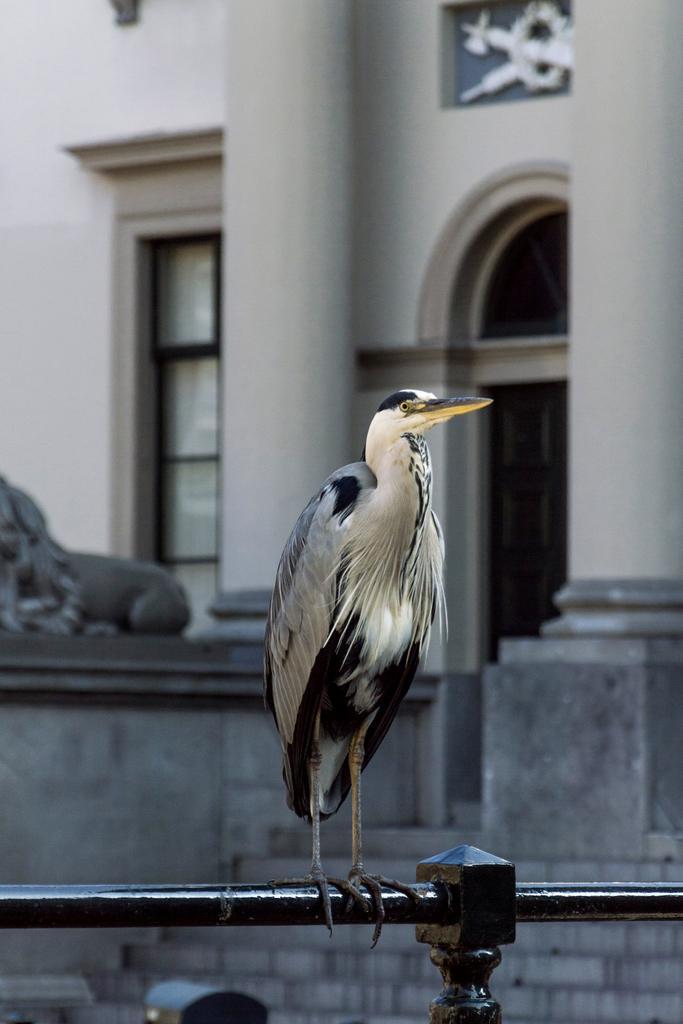Can you describe this image briefly? In this image I can see a bird standing on the rod. In the background, I can see the pillars and the wall. 